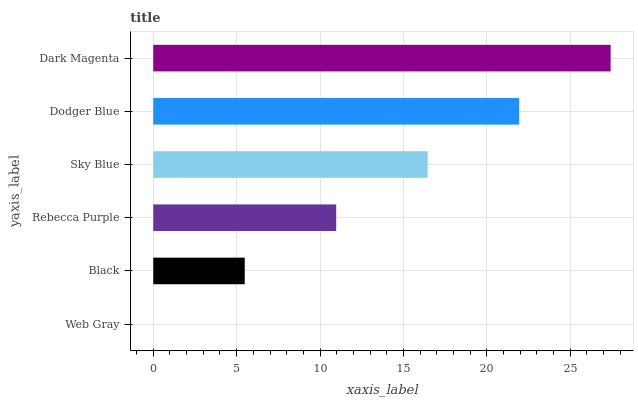Is Web Gray the minimum?
Answer yes or no. Yes. Is Dark Magenta the maximum?
Answer yes or no. Yes. Is Black the minimum?
Answer yes or no. No. Is Black the maximum?
Answer yes or no. No. Is Black greater than Web Gray?
Answer yes or no. Yes. Is Web Gray less than Black?
Answer yes or no. Yes. Is Web Gray greater than Black?
Answer yes or no. No. Is Black less than Web Gray?
Answer yes or no. No. Is Sky Blue the high median?
Answer yes or no. Yes. Is Rebecca Purple the low median?
Answer yes or no. Yes. Is Black the high median?
Answer yes or no. No. Is Web Gray the low median?
Answer yes or no. No. 